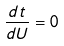Convert formula to latex. <formula><loc_0><loc_0><loc_500><loc_500>\frac { d t } { d U } = 0</formula> 